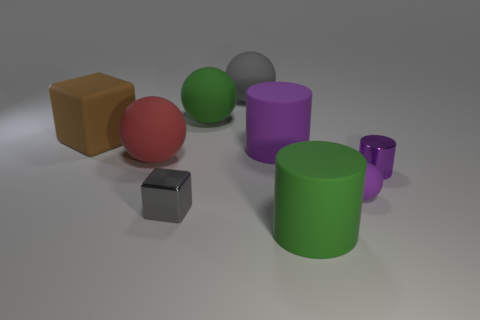There is a metal object on the right side of the large gray ball; what color is it?
Offer a terse response. Purple. Are there more big gray rubber things that are in front of the purple shiny object than gray balls?
Ensure brevity in your answer.  No. Does the big red sphere have the same material as the green cylinder?
Your response must be concise. Yes. What number of other things are there of the same shape as the brown rubber thing?
Give a very brief answer. 1. Is there anything else that has the same material as the large brown block?
Your answer should be compact. Yes. What is the color of the ball that is on the right side of the large cylinder that is behind the large cylinder that is in front of the purple shiny object?
Your response must be concise. Purple. There is a tiny purple object that is in front of the small metallic cylinder; is its shape the same as the purple metal object?
Ensure brevity in your answer.  No. What number of spheres are there?
Provide a succinct answer. 4. How many purple rubber cylinders have the same size as the red matte thing?
Your answer should be very brief. 1. What material is the large purple cylinder?
Ensure brevity in your answer.  Rubber. 